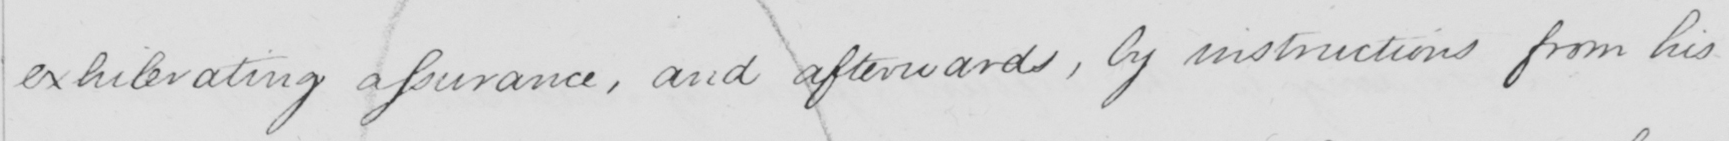Please transcribe the handwritten text in this image. exhilerating assurance , and afterwards , by instruction from his 